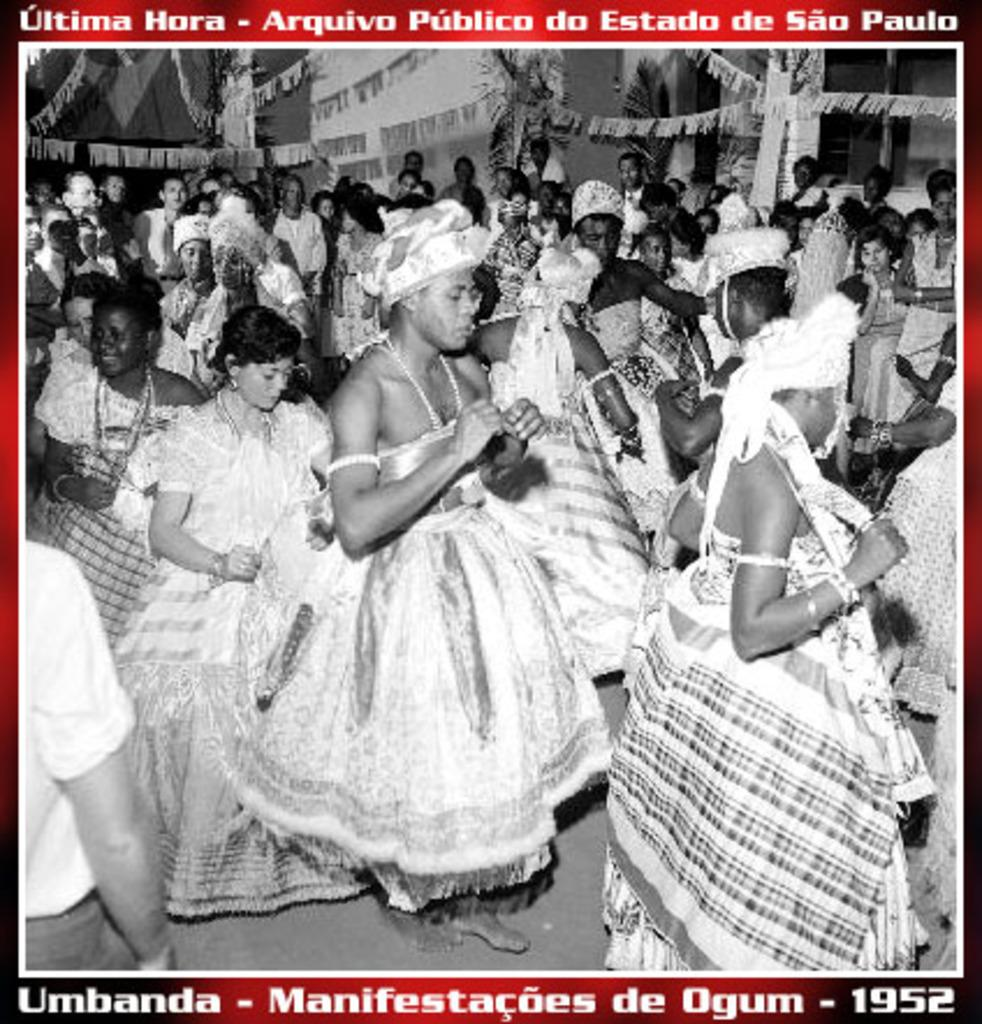What type of visual is the image? The image is a poster. What subjects are depicted on the poster? There are people and flags depicted on the poster. Is there any text present on the poster? Yes, there is text written on the poster. What type of suit is the person wearing in the image? There is no person wearing a suit in the image, as the subjects depicted are people and flags. 